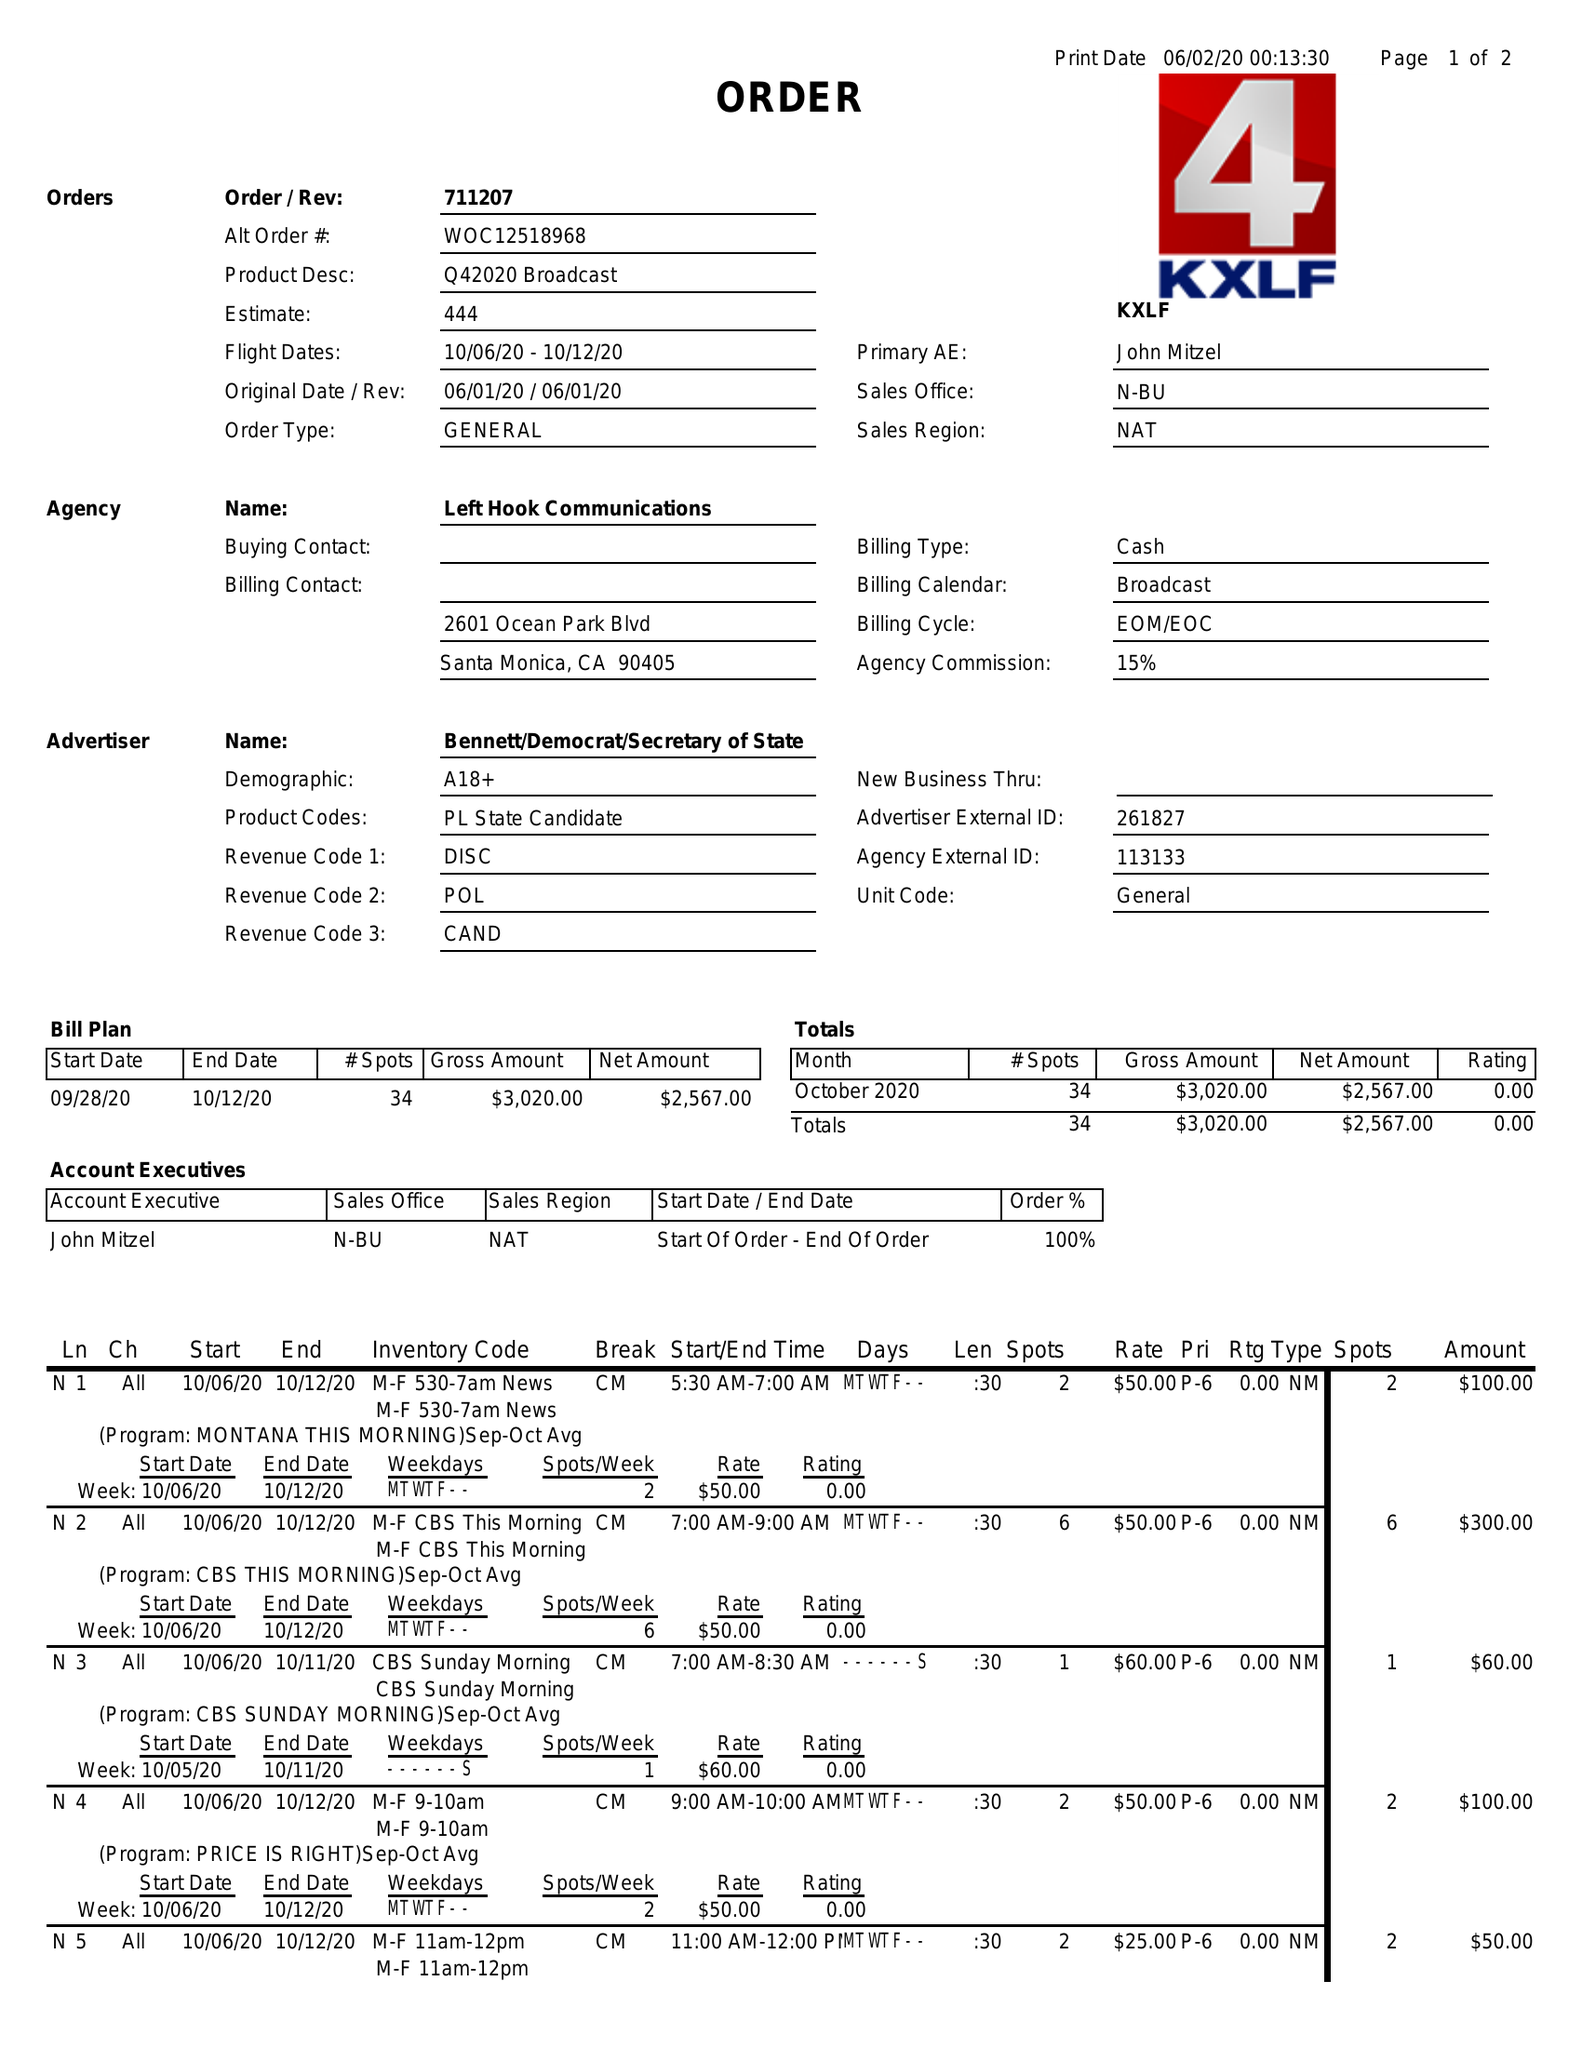What is the value for the flight_from?
Answer the question using a single word or phrase. 10/06/20 